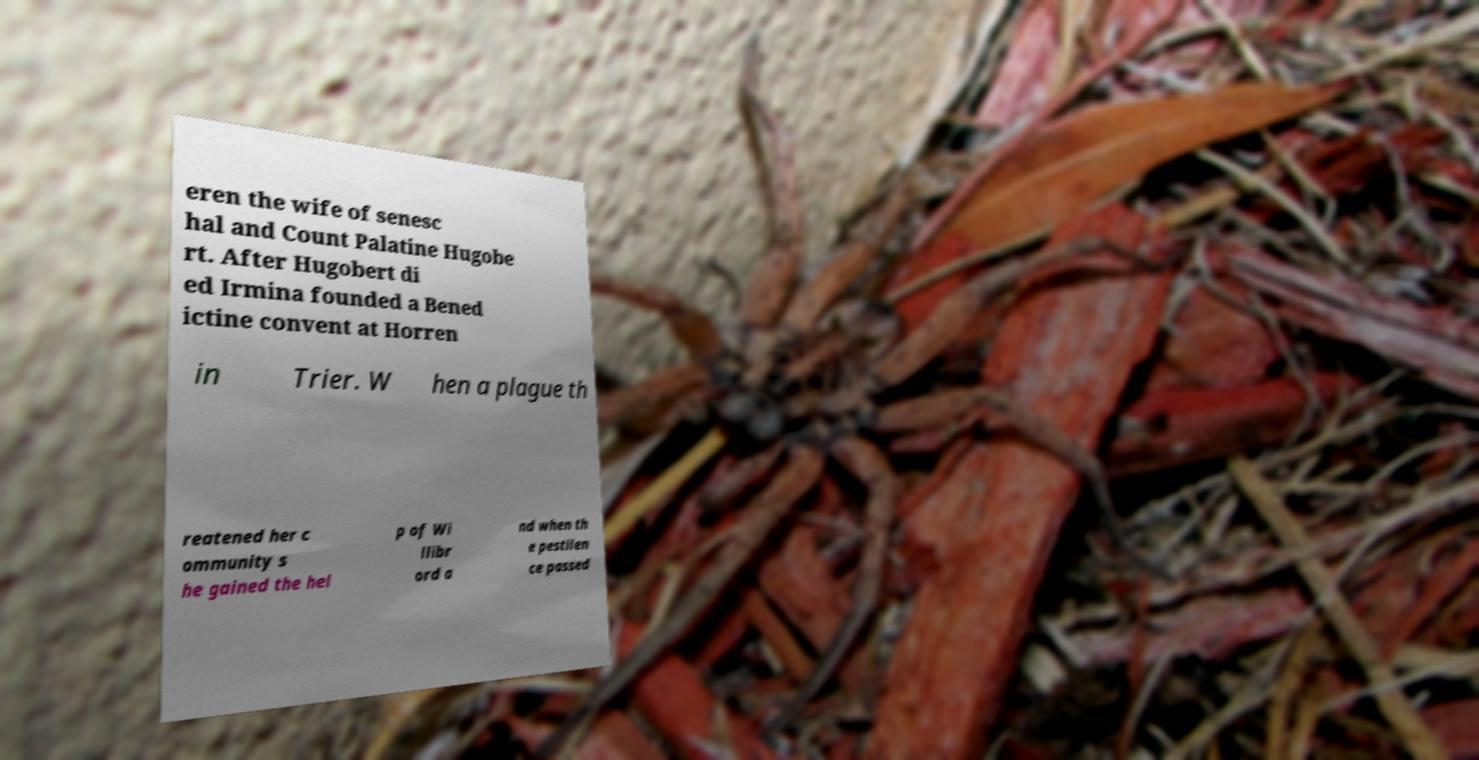Could you assist in decoding the text presented in this image and type it out clearly? eren the wife of senesc hal and Count Palatine Hugobe rt. After Hugobert di ed Irmina founded a Bened ictine convent at Horren in Trier. W hen a plague th reatened her c ommunity s he gained the hel p of Wi llibr ord a nd when th e pestilen ce passed 